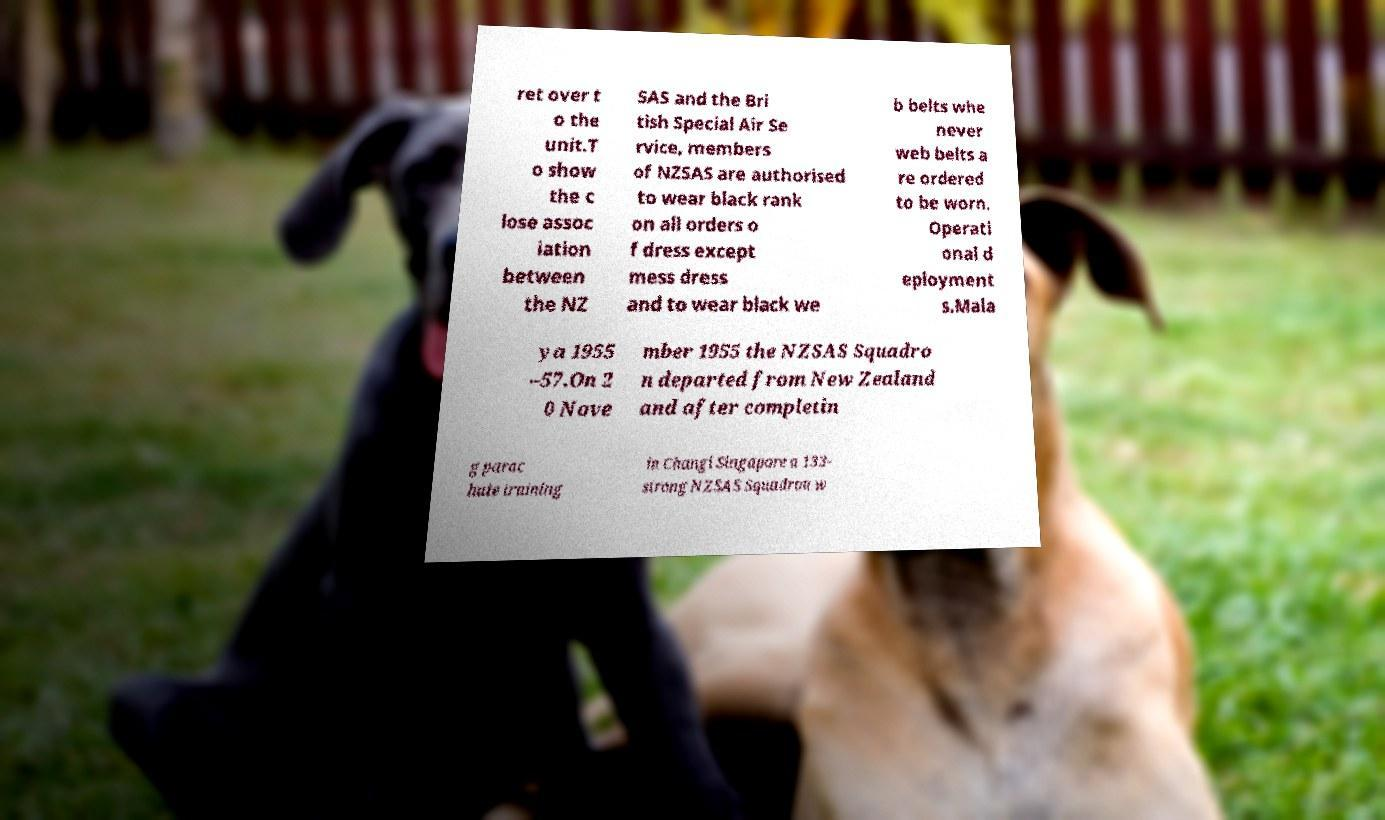There's text embedded in this image that I need extracted. Can you transcribe it verbatim? ret over t o the unit.T o show the c lose assoc iation between the NZ SAS and the Bri tish Special Air Se rvice, members of NZSAS are authorised to wear black rank on all orders o f dress except mess dress and to wear black we b belts whe never web belts a re ordered to be worn. Operati onal d eployment s.Mala ya 1955 –57.On 2 0 Nove mber 1955 the NZSAS Squadro n departed from New Zealand and after completin g parac hute training in Changi Singapore a 133- strong NZSAS Squadron w 